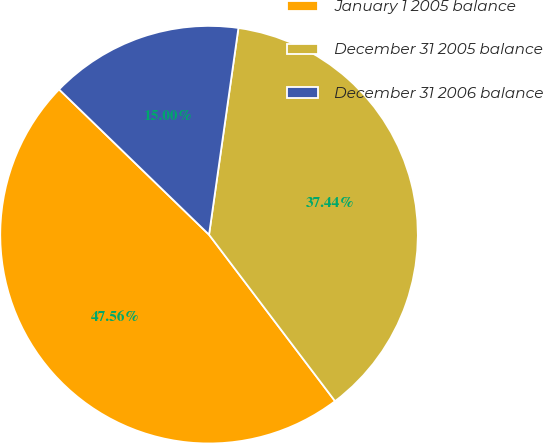Convert chart. <chart><loc_0><loc_0><loc_500><loc_500><pie_chart><fcel>January 1 2005 balance<fcel>December 31 2005 balance<fcel>December 31 2006 balance<nl><fcel>47.56%<fcel>37.44%<fcel>15.0%<nl></chart> 